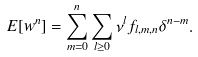<formula> <loc_0><loc_0><loc_500><loc_500>E [ w ^ { n } ] = \sum _ { m = 0 } ^ { n } \sum _ { l \geq 0 } \nu ^ { l } f _ { l , m , n } \delta ^ { n - m } .</formula> 